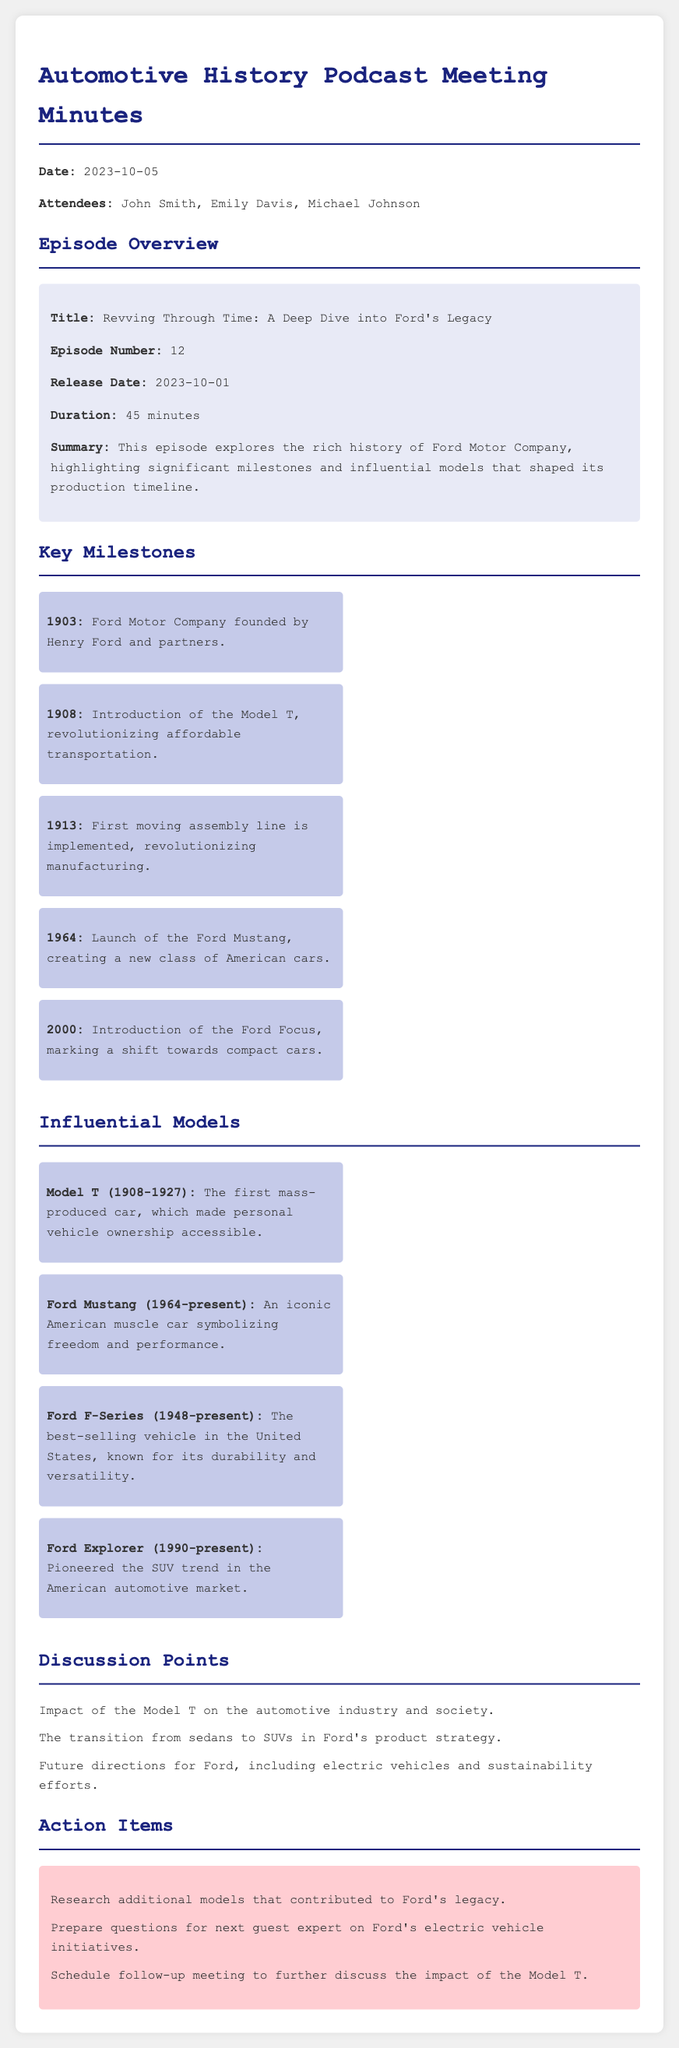What is the title of the podcast episode? The title is found in the episode overview section.
Answer: Revving Through Time: A Deep Dive into Ford's Legacy Who founded Ford Motor Company? The founder's name is mentioned in the key milestones section.
Answer: Henry Ford What year was the Model T introduced? The introduction year is stated in the key milestones section.
Answer: 1908 How long is the podcast episode? The duration is specified in the episode overview.
Answer: 45 minutes What significant manufacturing innovation did Ford implement in 1913? This innovation is highlighted in the key milestones section.
Answer: First moving assembly line Which model is known as the best-selling vehicle in the United States? The model is mentioned in the influential models section.
Answer: Ford F-Series What is one of the discussion points regarding Ford's product strategy? The discussion point is listed in the discussion points section.
Answer: Transition from sedans to SUVs When was the Ford Mustang launched? The launch year is indicated in the key milestones section.
Answer: 1964 What is one action item from the meeting? Action items are listed towards the end of the document.
Answer: Research additional models that contributed to Ford's legacy 